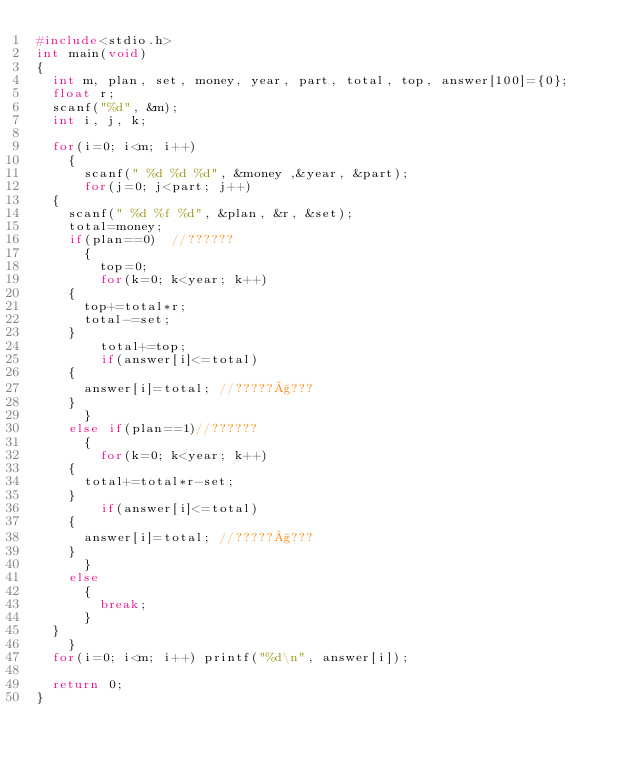Convert code to text. <code><loc_0><loc_0><loc_500><loc_500><_C_>#include<stdio.h>
int main(void)
{
  int m, plan, set, money, year, part, total, top, answer[100]={0}; 
  float r;
  scanf("%d", &m);
  int i, j, k;

  for(i=0; i<m; i++)
    {
      scanf(" %d %d %d", &money ,&year, &part);
      for(j=0; j<part; j++)
	{
	  scanf(" %d %f %d", &plan, &r, &set);
	  total=money;
	  if(plan==0)  //??????
	    {
	      top=0;
	      for(k=0; k<year; k++)
		{
		  top+=total*r;
		  total-=set;
		}
	      total+=top; 
	      if(answer[i]<=total)
		{
		  answer[i]=total; //?????§???   
		}   
	    }
	  else if(plan==1)//??????
	    {
	      for(k=0; k<year; k++)
		{
		  total+=total*r-set;	  
		}
	      if(answer[i]<=total)
		{
		  answer[i]=total; //?????§???   
		}
	    }
	  else
	    {
	      break;
	    }
	}
    }
  for(i=0; i<m; i++) printf("%d\n", answer[i]);

  return 0;
}</code> 